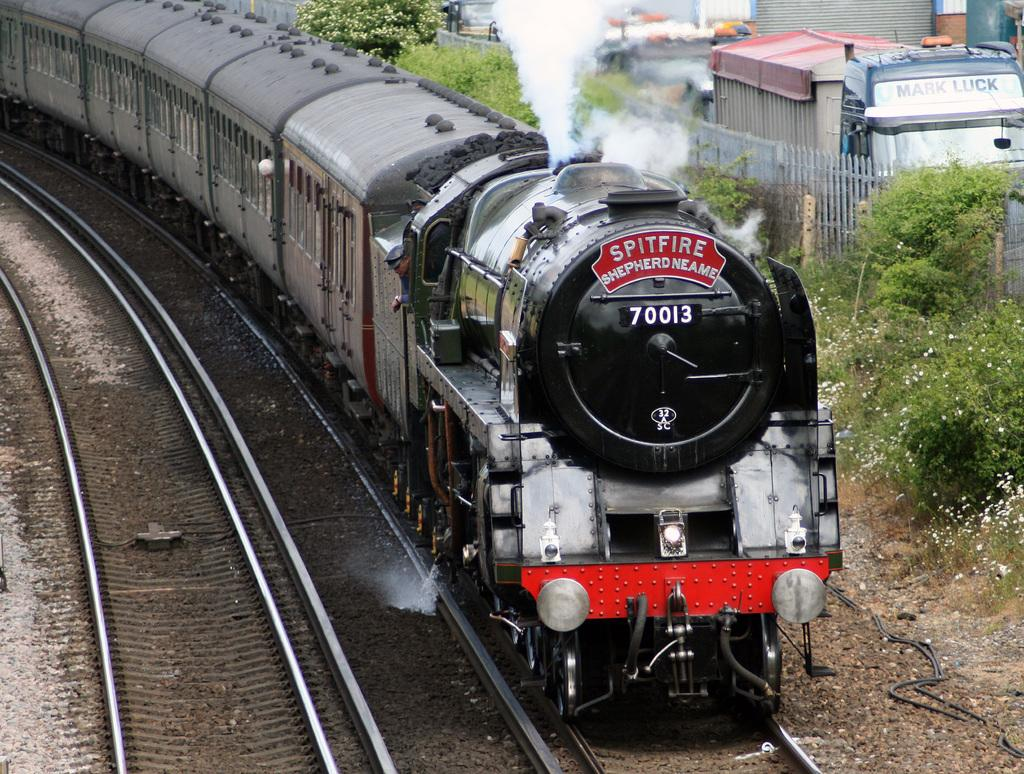<image>
Give a short and clear explanation of the subsequent image. A black train has the word Spitfire on the front. 